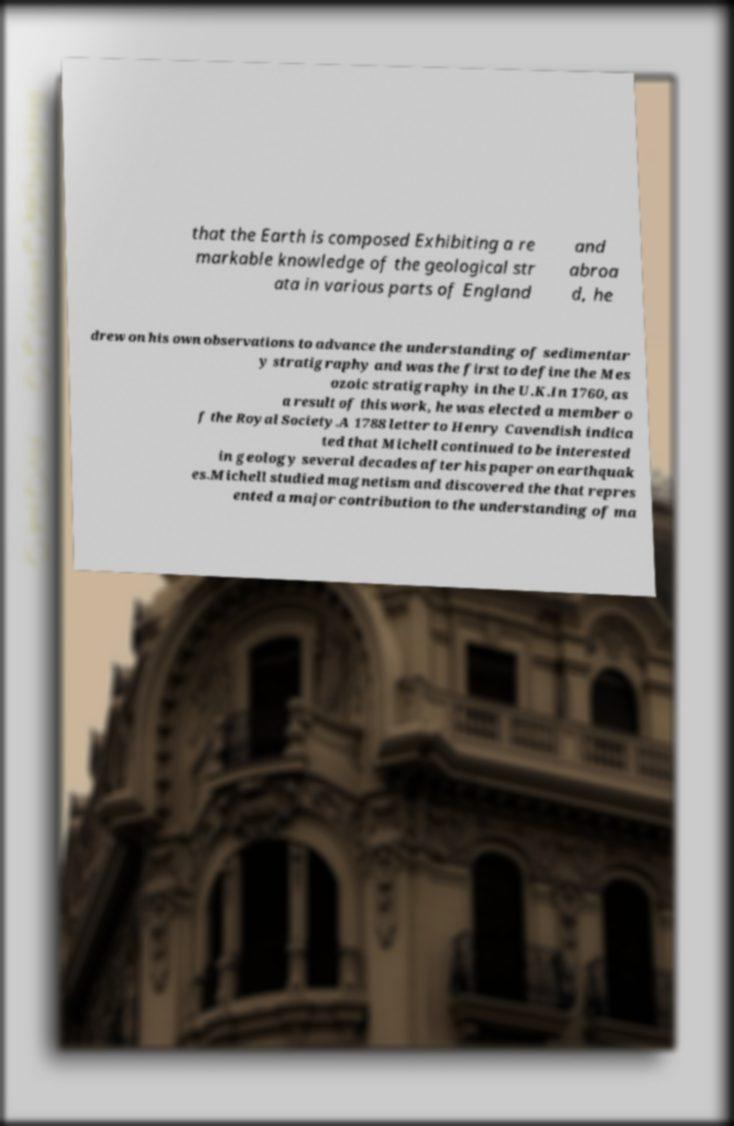I need the written content from this picture converted into text. Can you do that? that the Earth is composed Exhibiting a re markable knowledge of the geological str ata in various parts of England and abroa d, he drew on his own observations to advance the understanding of sedimentar y stratigraphy and was the first to define the Mes ozoic stratigraphy in the U.K.In 1760, as a result of this work, he was elected a member o f the Royal Society.A 1788 letter to Henry Cavendish indica ted that Michell continued to be interested in geology several decades after his paper on earthquak es.Michell studied magnetism and discovered the that repres ented a major contribution to the understanding of ma 